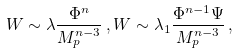Convert formula to latex. <formula><loc_0><loc_0><loc_500><loc_500>W \sim \lambda \frac { \Phi ^ { n } } { M _ { p } ^ { n - 3 } } \, , W \sim \lambda _ { 1 } \frac { \Phi ^ { n - 1 } \Psi } { M _ { p } ^ { n - 3 } } \, ,</formula> 